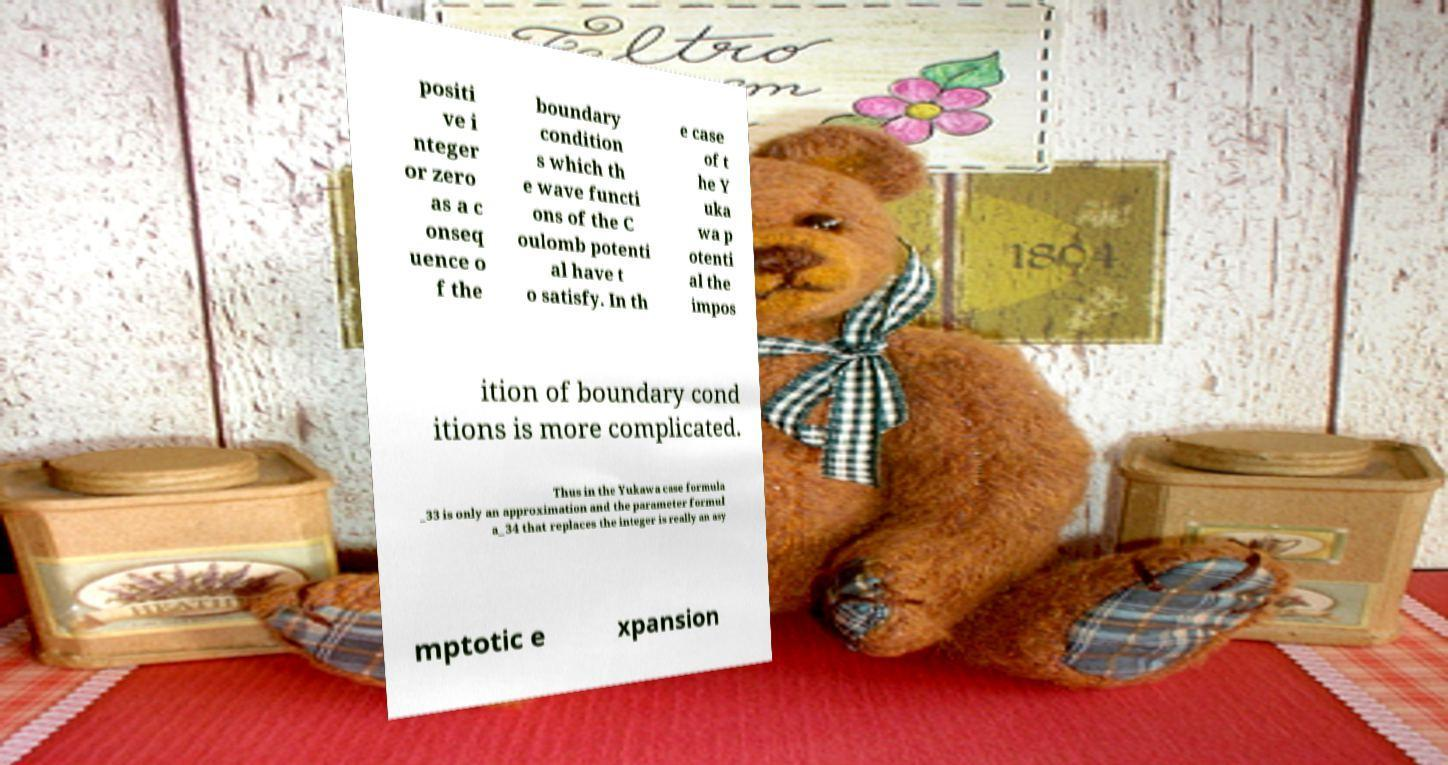Could you assist in decoding the text presented in this image and type it out clearly? positi ve i nteger or zero as a c onseq uence o f the boundary condition s which th e wave functi ons of the C oulomb potenti al have t o satisfy. In th e case of t he Y uka wa p otenti al the impos ition of boundary cond itions is more complicated. Thus in the Yukawa case formula _33 is only an approximation and the parameter formul a_34 that replaces the integer is really an asy mptotic e xpansion 